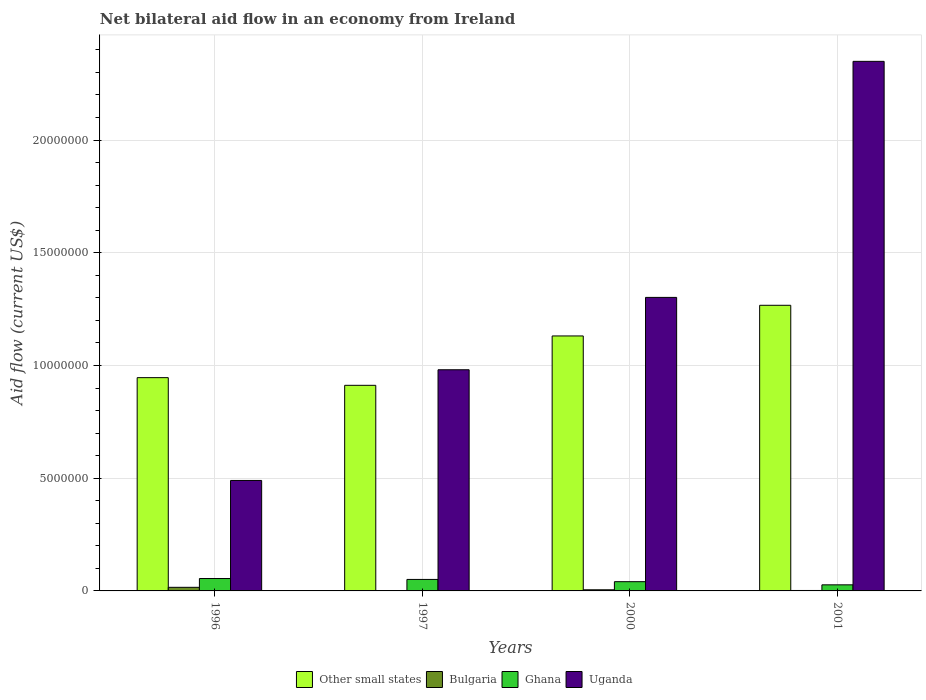How many groups of bars are there?
Your answer should be compact. 4. How many bars are there on the 2nd tick from the left?
Your answer should be very brief. 4. What is the label of the 2nd group of bars from the left?
Your answer should be compact. 1997. What is the net bilateral aid flow in Other small states in 2001?
Your response must be concise. 1.27e+07. Across all years, what is the maximum net bilateral aid flow in Bulgaria?
Your answer should be compact. 1.60e+05. Across all years, what is the minimum net bilateral aid flow in Ghana?
Your answer should be very brief. 2.70e+05. In which year was the net bilateral aid flow in Bulgaria maximum?
Your response must be concise. 1996. What is the total net bilateral aid flow in Other small states in the graph?
Provide a short and direct response. 4.26e+07. What is the difference between the net bilateral aid flow in Other small states in 1997 and that in 2000?
Provide a short and direct response. -2.19e+06. What is the difference between the net bilateral aid flow in Bulgaria in 1997 and the net bilateral aid flow in Uganda in 1996?
Provide a succinct answer. -4.89e+06. What is the average net bilateral aid flow in Other small states per year?
Provide a short and direct response. 1.06e+07. In the year 2001, what is the difference between the net bilateral aid flow in Other small states and net bilateral aid flow in Ghana?
Offer a very short reply. 1.24e+07. What is the ratio of the net bilateral aid flow in Ghana in 2000 to that in 2001?
Provide a short and direct response. 1.52. Is the net bilateral aid flow in Uganda in 1996 less than that in 2001?
Give a very brief answer. Yes. Is the difference between the net bilateral aid flow in Other small states in 2000 and 2001 greater than the difference between the net bilateral aid flow in Ghana in 2000 and 2001?
Make the answer very short. No. What is the difference between the highest and the second highest net bilateral aid flow in Other small states?
Your answer should be very brief. 1.36e+06. What is the difference between the highest and the lowest net bilateral aid flow in Ghana?
Give a very brief answer. 2.80e+05. Is the sum of the net bilateral aid flow in Other small states in 1996 and 2000 greater than the maximum net bilateral aid flow in Ghana across all years?
Your answer should be compact. Yes. What does the 2nd bar from the left in 2000 represents?
Give a very brief answer. Bulgaria. Is it the case that in every year, the sum of the net bilateral aid flow in Ghana and net bilateral aid flow in Other small states is greater than the net bilateral aid flow in Bulgaria?
Keep it short and to the point. Yes. Are all the bars in the graph horizontal?
Offer a terse response. No. What is the difference between two consecutive major ticks on the Y-axis?
Provide a succinct answer. 5.00e+06. Does the graph contain any zero values?
Provide a succinct answer. No. Does the graph contain grids?
Your response must be concise. Yes. What is the title of the graph?
Offer a terse response. Net bilateral aid flow in an economy from Ireland. Does "Germany" appear as one of the legend labels in the graph?
Ensure brevity in your answer.  No. What is the label or title of the X-axis?
Ensure brevity in your answer.  Years. What is the Aid flow (current US$) in Other small states in 1996?
Your response must be concise. 9.46e+06. What is the Aid flow (current US$) of Bulgaria in 1996?
Ensure brevity in your answer.  1.60e+05. What is the Aid flow (current US$) of Ghana in 1996?
Your answer should be compact. 5.50e+05. What is the Aid flow (current US$) in Uganda in 1996?
Make the answer very short. 4.90e+06. What is the Aid flow (current US$) in Other small states in 1997?
Ensure brevity in your answer.  9.12e+06. What is the Aid flow (current US$) in Bulgaria in 1997?
Provide a short and direct response. 10000. What is the Aid flow (current US$) in Ghana in 1997?
Offer a very short reply. 5.10e+05. What is the Aid flow (current US$) of Uganda in 1997?
Your answer should be compact. 9.81e+06. What is the Aid flow (current US$) in Other small states in 2000?
Your answer should be very brief. 1.13e+07. What is the Aid flow (current US$) in Ghana in 2000?
Offer a terse response. 4.10e+05. What is the Aid flow (current US$) in Uganda in 2000?
Offer a very short reply. 1.30e+07. What is the Aid flow (current US$) of Other small states in 2001?
Give a very brief answer. 1.27e+07. What is the Aid flow (current US$) of Bulgaria in 2001?
Your response must be concise. 2.00e+04. What is the Aid flow (current US$) of Uganda in 2001?
Provide a short and direct response. 2.35e+07. Across all years, what is the maximum Aid flow (current US$) in Other small states?
Give a very brief answer. 1.27e+07. Across all years, what is the maximum Aid flow (current US$) of Bulgaria?
Offer a terse response. 1.60e+05. Across all years, what is the maximum Aid flow (current US$) of Ghana?
Your response must be concise. 5.50e+05. Across all years, what is the maximum Aid flow (current US$) of Uganda?
Provide a succinct answer. 2.35e+07. Across all years, what is the minimum Aid flow (current US$) in Other small states?
Give a very brief answer. 9.12e+06. Across all years, what is the minimum Aid flow (current US$) in Bulgaria?
Your answer should be very brief. 10000. Across all years, what is the minimum Aid flow (current US$) in Ghana?
Make the answer very short. 2.70e+05. Across all years, what is the minimum Aid flow (current US$) in Uganda?
Offer a terse response. 4.90e+06. What is the total Aid flow (current US$) of Other small states in the graph?
Provide a succinct answer. 4.26e+07. What is the total Aid flow (current US$) of Ghana in the graph?
Provide a short and direct response. 1.74e+06. What is the total Aid flow (current US$) of Uganda in the graph?
Offer a very short reply. 5.12e+07. What is the difference between the Aid flow (current US$) in Uganda in 1996 and that in 1997?
Give a very brief answer. -4.91e+06. What is the difference between the Aid flow (current US$) in Other small states in 1996 and that in 2000?
Your answer should be very brief. -1.85e+06. What is the difference between the Aid flow (current US$) in Bulgaria in 1996 and that in 2000?
Your answer should be compact. 1.10e+05. What is the difference between the Aid flow (current US$) in Ghana in 1996 and that in 2000?
Make the answer very short. 1.40e+05. What is the difference between the Aid flow (current US$) of Uganda in 1996 and that in 2000?
Offer a very short reply. -8.12e+06. What is the difference between the Aid flow (current US$) in Other small states in 1996 and that in 2001?
Offer a terse response. -3.21e+06. What is the difference between the Aid flow (current US$) in Bulgaria in 1996 and that in 2001?
Keep it short and to the point. 1.40e+05. What is the difference between the Aid flow (current US$) of Uganda in 1996 and that in 2001?
Offer a terse response. -1.86e+07. What is the difference between the Aid flow (current US$) in Other small states in 1997 and that in 2000?
Ensure brevity in your answer.  -2.19e+06. What is the difference between the Aid flow (current US$) of Ghana in 1997 and that in 2000?
Ensure brevity in your answer.  1.00e+05. What is the difference between the Aid flow (current US$) of Uganda in 1997 and that in 2000?
Your answer should be very brief. -3.21e+06. What is the difference between the Aid flow (current US$) in Other small states in 1997 and that in 2001?
Make the answer very short. -3.55e+06. What is the difference between the Aid flow (current US$) of Ghana in 1997 and that in 2001?
Your answer should be compact. 2.40e+05. What is the difference between the Aid flow (current US$) in Uganda in 1997 and that in 2001?
Ensure brevity in your answer.  -1.37e+07. What is the difference between the Aid flow (current US$) in Other small states in 2000 and that in 2001?
Your answer should be compact. -1.36e+06. What is the difference between the Aid flow (current US$) in Ghana in 2000 and that in 2001?
Provide a succinct answer. 1.40e+05. What is the difference between the Aid flow (current US$) in Uganda in 2000 and that in 2001?
Provide a succinct answer. -1.05e+07. What is the difference between the Aid flow (current US$) in Other small states in 1996 and the Aid flow (current US$) in Bulgaria in 1997?
Provide a succinct answer. 9.45e+06. What is the difference between the Aid flow (current US$) in Other small states in 1996 and the Aid flow (current US$) in Ghana in 1997?
Ensure brevity in your answer.  8.95e+06. What is the difference between the Aid flow (current US$) in Other small states in 1996 and the Aid flow (current US$) in Uganda in 1997?
Your answer should be very brief. -3.50e+05. What is the difference between the Aid flow (current US$) of Bulgaria in 1996 and the Aid flow (current US$) of Ghana in 1997?
Your response must be concise. -3.50e+05. What is the difference between the Aid flow (current US$) in Bulgaria in 1996 and the Aid flow (current US$) in Uganda in 1997?
Your answer should be compact. -9.65e+06. What is the difference between the Aid flow (current US$) of Ghana in 1996 and the Aid flow (current US$) of Uganda in 1997?
Your answer should be very brief. -9.26e+06. What is the difference between the Aid flow (current US$) in Other small states in 1996 and the Aid flow (current US$) in Bulgaria in 2000?
Ensure brevity in your answer.  9.41e+06. What is the difference between the Aid flow (current US$) of Other small states in 1996 and the Aid flow (current US$) of Ghana in 2000?
Give a very brief answer. 9.05e+06. What is the difference between the Aid flow (current US$) in Other small states in 1996 and the Aid flow (current US$) in Uganda in 2000?
Your answer should be very brief. -3.56e+06. What is the difference between the Aid flow (current US$) of Bulgaria in 1996 and the Aid flow (current US$) of Uganda in 2000?
Provide a short and direct response. -1.29e+07. What is the difference between the Aid flow (current US$) of Ghana in 1996 and the Aid flow (current US$) of Uganda in 2000?
Provide a succinct answer. -1.25e+07. What is the difference between the Aid flow (current US$) in Other small states in 1996 and the Aid flow (current US$) in Bulgaria in 2001?
Ensure brevity in your answer.  9.44e+06. What is the difference between the Aid flow (current US$) in Other small states in 1996 and the Aid flow (current US$) in Ghana in 2001?
Offer a very short reply. 9.19e+06. What is the difference between the Aid flow (current US$) in Other small states in 1996 and the Aid flow (current US$) in Uganda in 2001?
Keep it short and to the point. -1.40e+07. What is the difference between the Aid flow (current US$) of Bulgaria in 1996 and the Aid flow (current US$) of Ghana in 2001?
Give a very brief answer. -1.10e+05. What is the difference between the Aid flow (current US$) of Bulgaria in 1996 and the Aid flow (current US$) of Uganda in 2001?
Make the answer very short. -2.33e+07. What is the difference between the Aid flow (current US$) in Ghana in 1996 and the Aid flow (current US$) in Uganda in 2001?
Ensure brevity in your answer.  -2.29e+07. What is the difference between the Aid flow (current US$) in Other small states in 1997 and the Aid flow (current US$) in Bulgaria in 2000?
Make the answer very short. 9.07e+06. What is the difference between the Aid flow (current US$) in Other small states in 1997 and the Aid flow (current US$) in Ghana in 2000?
Give a very brief answer. 8.71e+06. What is the difference between the Aid flow (current US$) of Other small states in 1997 and the Aid flow (current US$) of Uganda in 2000?
Provide a short and direct response. -3.90e+06. What is the difference between the Aid flow (current US$) of Bulgaria in 1997 and the Aid flow (current US$) of Ghana in 2000?
Make the answer very short. -4.00e+05. What is the difference between the Aid flow (current US$) in Bulgaria in 1997 and the Aid flow (current US$) in Uganda in 2000?
Keep it short and to the point. -1.30e+07. What is the difference between the Aid flow (current US$) of Ghana in 1997 and the Aid flow (current US$) of Uganda in 2000?
Provide a succinct answer. -1.25e+07. What is the difference between the Aid flow (current US$) of Other small states in 1997 and the Aid flow (current US$) of Bulgaria in 2001?
Keep it short and to the point. 9.10e+06. What is the difference between the Aid flow (current US$) in Other small states in 1997 and the Aid flow (current US$) in Ghana in 2001?
Your answer should be very brief. 8.85e+06. What is the difference between the Aid flow (current US$) of Other small states in 1997 and the Aid flow (current US$) of Uganda in 2001?
Keep it short and to the point. -1.44e+07. What is the difference between the Aid flow (current US$) of Bulgaria in 1997 and the Aid flow (current US$) of Uganda in 2001?
Your answer should be very brief. -2.35e+07. What is the difference between the Aid flow (current US$) in Ghana in 1997 and the Aid flow (current US$) in Uganda in 2001?
Provide a succinct answer. -2.30e+07. What is the difference between the Aid flow (current US$) of Other small states in 2000 and the Aid flow (current US$) of Bulgaria in 2001?
Provide a short and direct response. 1.13e+07. What is the difference between the Aid flow (current US$) of Other small states in 2000 and the Aid flow (current US$) of Ghana in 2001?
Offer a very short reply. 1.10e+07. What is the difference between the Aid flow (current US$) of Other small states in 2000 and the Aid flow (current US$) of Uganda in 2001?
Offer a terse response. -1.22e+07. What is the difference between the Aid flow (current US$) of Bulgaria in 2000 and the Aid flow (current US$) of Uganda in 2001?
Offer a terse response. -2.34e+07. What is the difference between the Aid flow (current US$) of Ghana in 2000 and the Aid flow (current US$) of Uganda in 2001?
Your answer should be very brief. -2.31e+07. What is the average Aid flow (current US$) of Other small states per year?
Make the answer very short. 1.06e+07. What is the average Aid flow (current US$) in Ghana per year?
Your response must be concise. 4.35e+05. What is the average Aid flow (current US$) in Uganda per year?
Offer a very short reply. 1.28e+07. In the year 1996, what is the difference between the Aid flow (current US$) in Other small states and Aid flow (current US$) in Bulgaria?
Ensure brevity in your answer.  9.30e+06. In the year 1996, what is the difference between the Aid flow (current US$) of Other small states and Aid flow (current US$) of Ghana?
Give a very brief answer. 8.91e+06. In the year 1996, what is the difference between the Aid flow (current US$) of Other small states and Aid flow (current US$) of Uganda?
Your answer should be very brief. 4.56e+06. In the year 1996, what is the difference between the Aid flow (current US$) of Bulgaria and Aid flow (current US$) of Ghana?
Your answer should be very brief. -3.90e+05. In the year 1996, what is the difference between the Aid flow (current US$) in Bulgaria and Aid flow (current US$) in Uganda?
Provide a succinct answer. -4.74e+06. In the year 1996, what is the difference between the Aid flow (current US$) in Ghana and Aid flow (current US$) in Uganda?
Your answer should be compact. -4.35e+06. In the year 1997, what is the difference between the Aid flow (current US$) of Other small states and Aid flow (current US$) of Bulgaria?
Ensure brevity in your answer.  9.11e+06. In the year 1997, what is the difference between the Aid flow (current US$) in Other small states and Aid flow (current US$) in Ghana?
Your response must be concise. 8.61e+06. In the year 1997, what is the difference between the Aid flow (current US$) of Other small states and Aid flow (current US$) of Uganda?
Keep it short and to the point. -6.90e+05. In the year 1997, what is the difference between the Aid flow (current US$) in Bulgaria and Aid flow (current US$) in Ghana?
Provide a succinct answer. -5.00e+05. In the year 1997, what is the difference between the Aid flow (current US$) in Bulgaria and Aid flow (current US$) in Uganda?
Your response must be concise. -9.80e+06. In the year 1997, what is the difference between the Aid flow (current US$) in Ghana and Aid flow (current US$) in Uganda?
Offer a very short reply. -9.30e+06. In the year 2000, what is the difference between the Aid flow (current US$) of Other small states and Aid flow (current US$) of Bulgaria?
Your answer should be compact. 1.13e+07. In the year 2000, what is the difference between the Aid flow (current US$) of Other small states and Aid flow (current US$) of Ghana?
Ensure brevity in your answer.  1.09e+07. In the year 2000, what is the difference between the Aid flow (current US$) of Other small states and Aid flow (current US$) of Uganda?
Offer a terse response. -1.71e+06. In the year 2000, what is the difference between the Aid flow (current US$) of Bulgaria and Aid flow (current US$) of Ghana?
Offer a terse response. -3.60e+05. In the year 2000, what is the difference between the Aid flow (current US$) of Bulgaria and Aid flow (current US$) of Uganda?
Give a very brief answer. -1.30e+07. In the year 2000, what is the difference between the Aid flow (current US$) in Ghana and Aid flow (current US$) in Uganda?
Offer a terse response. -1.26e+07. In the year 2001, what is the difference between the Aid flow (current US$) of Other small states and Aid flow (current US$) of Bulgaria?
Keep it short and to the point. 1.26e+07. In the year 2001, what is the difference between the Aid flow (current US$) in Other small states and Aid flow (current US$) in Ghana?
Ensure brevity in your answer.  1.24e+07. In the year 2001, what is the difference between the Aid flow (current US$) of Other small states and Aid flow (current US$) of Uganda?
Offer a very short reply. -1.08e+07. In the year 2001, what is the difference between the Aid flow (current US$) in Bulgaria and Aid flow (current US$) in Uganda?
Provide a short and direct response. -2.35e+07. In the year 2001, what is the difference between the Aid flow (current US$) in Ghana and Aid flow (current US$) in Uganda?
Your response must be concise. -2.32e+07. What is the ratio of the Aid flow (current US$) of Other small states in 1996 to that in 1997?
Your answer should be very brief. 1.04. What is the ratio of the Aid flow (current US$) in Ghana in 1996 to that in 1997?
Provide a short and direct response. 1.08. What is the ratio of the Aid flow (current US$) of Uganda in 1996 to that in 1997?
Your answer should be very brief. 0.5. What is the ratio of the Aid flow (current US$) of Other small states in 1996 to that in 2000?
Make the answer very short. 0.84. What is the ratio of the Aid flow (current US$) of Bulgaria in 1996 to that in 2000?
Your answer should be compact. 3.2. What is the ratio of the Aid flow (current US$) of Ghana in 1996 to that in 2000?
Provide a succinct answer. 1.34. What is the ratio of the Aid flow (current US$) of Uganda in 1996 to that in 2000?
Make the answer very short. 0.38. What is the ratio of the Aid flow (current US$) of Other small states in 1996 to that in 2001?
Give a very brief answer. 0.75. What is the ratio of the Aid flow (current US$) of Ghana in 1996 to that in 2001?
Your answer should be very brief. 2.04. What is the ratio of the Aid flow (current US$) of Uganda in 1996 to that in 2001?
Your answer should be very brief. 0.21. What is the ratio of the Aid flow (current US$) of Other small states in 1997 to that in 2000?
Ensure brevity in your answer.  0.81. What is the ratio of the Aid flow (current US$) in Bulgaria in 1997 to that in 2000?
Your response must be concise. 0.2. What is the ratio of the Aid flow (current US$) in Ghana in 1997 to that in 2000?
Make the answer very short. 1.24. What is the ratio of the Aid flow (current US$) in Uganda in 1997 to that in 2000?
Provide a short and direct response. 0.75. What is the ratio of the Aid flow (current US$) of Other small states in 1997 to that in 2001?
Your response must be concise. 0.72. What is the ratio of the Aid flow (current US$) of Ghana in 1997 to that in 2001?
Ensure brevity in your answer.  1.89. What is the ratio of the Aid flow (current US$) in Uganda in 1997 to that in 2001?
Your answer should be compact. 0.42. What is the ratio of the Aid flow (current US$) of Other small states in 2000 to that in 2001?
Your response must be concise. 0.89. What is the ratio of the Aid flow (current US$) in Ghana in 2000 to that in 2001?
Your response must be concise. 1.52. What is the ratio of the Aid flow (current US$) of Uganda in 2000 to that in 2001?
Your response must be concise. 0.55. What is the difference between the highest and the second highest Aid flow (current US$) in Other small states?
Your response must be concise. 1.36e+06. What is the difference between the highest and the second highest Aid flow (current US$) in Uganda?
Provide a short and direct response. 1.05e+07. What is the difference between the highest and the lowest Aid flow (current US$) in Other small states?
Provide a succinct answer. 3.55e+06. What is the difference between the highest and the lowest Aid flow (current US$) of Bulgaria?
Keep it short and to the point. 1.50e+05. What is the difference between the highest and the lowest Aid flow (current US$) of Uganda?
Offer a very short reply. 1.86e+07. 